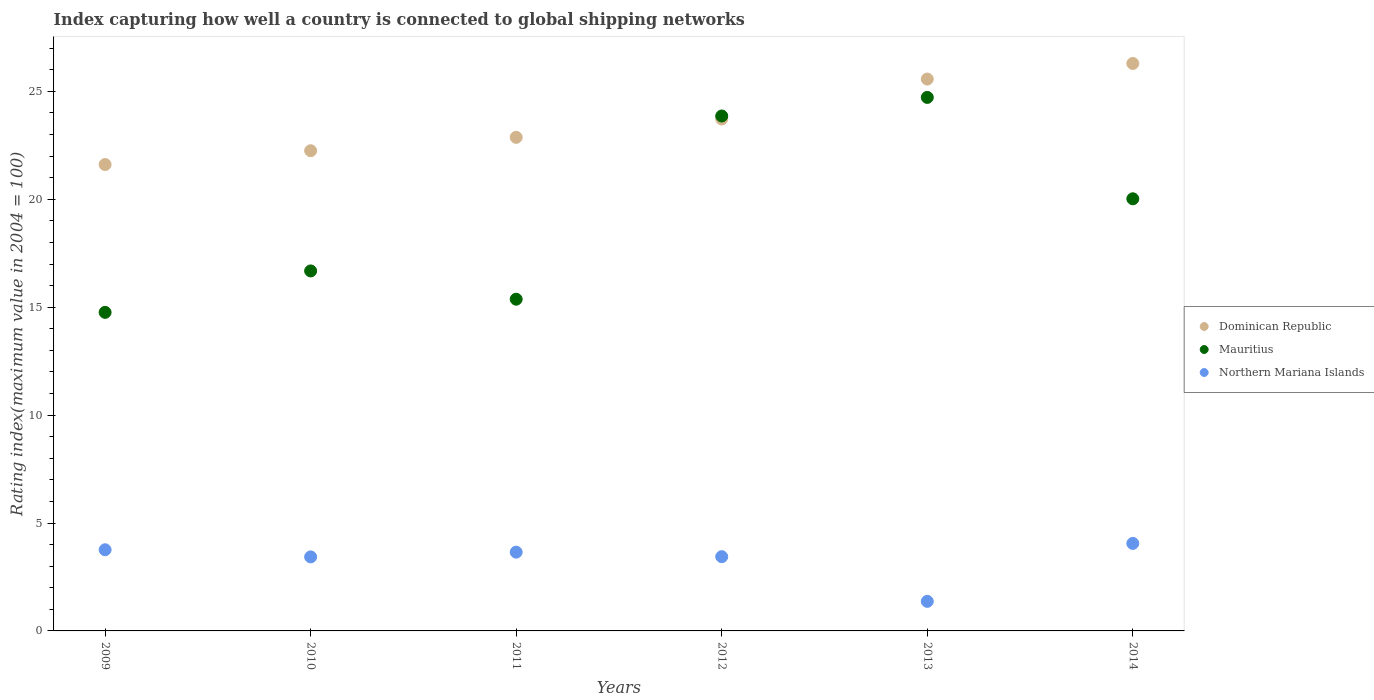What is the rating index in Dominican Republic in 2010?
Your response must be concise. 22.25. Across all years, what is the maximum rating index in Northern Mariana Islands?
Provide a short and direct response. 4.06. Across all years, what is the minimum rating index in Dominican Republic?
Offer a very short reply. 21.61. In which year was the rating index in Mauritius minimum?
Provide a short and direct response. 2009. What is the total rating index in Mauritius in the graph?
Your answer should be very brief. 115.41. What is the difference between the rating index in Dominican Republic in 2012 and that in 2013?
Your answer should be compact. -1.85. What is the difference between the rating index in Northern Mariana Islands in 2011 and the rating index in Mauritius in 2014?
Ensure brevity in your answer.  -16.37. What is the average rating index in Dominican Republic per year?
Keep it short and to the point. 23.72. In the year 2011, what is the difference between the rating index in Northern Mariana Islands and rating index in Mauritius?
Your answer should be compact. -11.72. What is the ratio of the rating index in Dominican Republic in 2010 to that in 2014?
Give a very brief answer. 0.85. Is the rating index in Northern Mariana Islands in 2009 less than that in 2012?
Your answer should be compact. No. Is the difference between the rating index in Northern Mariana Islands in 2011 and 2014 greater than the difference between the rating index in Mauritius in 2011 and 2014?
Ensure brevity in your answer.  Yes. What is the difference between the highest and the second highest rating index in Mauritius?
Your answer should be very brief. 0.86. What is the difference between the highest and the lowest rating index in Mauritius?
Ensure brevity in your answer.  9.96. Is it the case that in every year, the sum of the rating index in Mauritius and rating index in Dominican Republic  is greater than the rating index in Northern Mariana Islands?
Make the answer very short. Yes. Does the rating index in Mauritius monotonically increase over the years?
Your answer should be compact. No. How many years are there in the graph?
Provide a succinct answer. 6. What is the difference between two consecutive major ticks on the Y-axis?
Provide a short and direct response. 5. Does the graph contain any zero values?
Provide a short and direct response. No. Does the graph contain grids?
Keep it short and to the point. No. What is the title of the graph?
Your answer should be compact. Index capturing how well a country is connected to global shipping networks. Does "Vietnam" appear as one of the legend labels in the graph?
Provide a short and direct response. No. What is the label or title of the Y-axis?
Your response must be concise. Rating index(maximum value in 2004 = 100). What is the Rating index(maximum value in 2004 = 100) in Dominican Republic in 2009?
Your answer should be very brief. 21.61. What is the Rating index(maximum value in 2004 = 100) in Mauritius in 2009?
Offer a very short reply. 14.76. What is the Rating index(maximum value in 2004 = 100) of Northern Mariana Islands in 2009?
Give a very brief answer. 3.76. What is the Rating index(maximum value in 2004 = 100) in Dominican Republic in 2010?
Provide a short and direct response. 22.25. What is the Rating index(maximum value in 2004 = 100) in Mauritius in 2010?
Your answer should be very brief. 16.68. What is the Rating index(maximum value in 2004 = 100) in Northern Mariana Islands in 2010?
Your answer should be compact. 3.43. What is the Rating index(maximum value in 2004 = 100) of Dominican Republic in 2011?
Make the answer very short. 22.87. What is the Rating index(maximum value in 2004 = 100) of Mauritius in 2011?
Your answer should be compact. 15.37. What is the Rating index(maximum value in 2004 = 100) of Northern Mariana Islands in 2011?
Your answer should be compact. 3.65. What is the Rating index(maximum value in 2004 = 100) in Dominican Republic in 2012?
Your answer should be very brief. 23.72. What is the Rating index(maximum value in 2004 = 100) of Mauritius in 2012?
Give a very brief answer. 23.86. What is the Rating index(maximum value in 2004 = 100) of Northern Mariana Islands in 2012?
Offer a terse response. 3.44. What is the Rating index(maximum value in 2004 = 100) in Dominican Republic in 2013?
Your answer should be compact. 25.57. What is the Rating index(maximum value in 2004 = 100) in Mauritius in 2013?
Keep it short and to the point. 24.72. What is the Rating index(maximum value in 2004 = 100) of Northern Mariana Islands in 2013?
Offer a terse response. 1.37. What is the Rating index(maximum value in 2004 = 100) in Dominican Republic in 2014?
Your response must be concise. 26.29. What is the Rating index(maximum value in 2004 = 100) in Mauritius in 2014?
Offer a terse response. 20.02. What is the Rating index(maximum value in 2004 = 100) in Northern Mariana Islands in 2014?
Your answer should be compact. 4.06. Across all years, what is the maximum Rating index(maximum value in 2004 = 100) in Dominican Republic?
Offer a terse response. 26.29. Across all years, what is the maximum Rating index(maximum value in 2004 = 100) of Mauritius?
Your response must be concise. 24.72. Across all years, what is the maximum Rating index(maximum value in 2004 = 100) in Northern Mariana Islands?
Offer a terse response. 4.06. Across all years, what is the minimum Rating index(maximum value in 2004 = 100) of Dominican Republic?
Offer a very short reply. 21.61. Across all years, what is the minimum Rating index(maximum value in 2004 = 100) in Mauritius?
Ensure brevity in your answer.  14.76. Across all years, what is the minimum Rating index(maximum value in 2004 = 100) in Northern Mariana Islands?
Provide a short and direct response. 1.37. What is the total Rating index(maximum value in 2004 = 100) of Dominican Republic in the graph?
Make the answer very short. 142.31. What is the total Rating index(maximum value in 2004 = 100) in Mauritius in the graph?
Your answer should be compact. 115.41. What is the total Rating index(maximum value in 2004 = 100) of Northern Mariana Islands in the graph?
Your response must be concise. 19.7. What is the difference between the Rating index(maximum value in 2004 = 100) in Dominican Republic in 2009 and that in 2010?
Give a very brief answer. -0.64. What is the difference between the Rating index(maximum value in 2004 = 100) of Mauritius in 2009 and that in 2010?
Provide a short and direct response. -1.92. What is the difference between the Rating index(maximum value in 2004 = 100) in Northern Mariana Islands in 2009 and that in 2010?
Make the answer very short. 0.33. What is the difference between the Rating index(maximum value in 2004 = 100) in Dominican Republic in 2009 and that in 2011?
Make the answer very short. -1.26. What is the difference between the Rating index(maximum value in 2004 = 100) in Mauritius in 2009 and that in 2011?
Offer a terse response. -0.61. What is the difference between the Rating index(maximum value in 2004 = 100) of Northern Mariana Islands in 2009 and that in 2011?
Your response must be concise. 0.11. What is the difference between the Rating index(maximum value in 2004 = 100) in Dominican Republic in 2009 and that in 2012?
Offer a terse response. -2.11. What is the difference between the Rating index(maximum value in 2004 = 100) in Northern Mariana Islands in 2009 and that in 2012?
Offer a terse response. 0.32. What is the difference between the Rating index(maximum value in 2004 = 100) in Dominican Republic in 2009 and that in 2013?
Your answer should be very brief. -3.96. What is the difference between the Rating index(maximum value in 2004 = 100) of Mauritius in 2009 and that in 2013?
Make the answer very short. -9.96. What is the difference between the Rating index(maximum value in 2004 = 100) in Northern Mariana Islands in 2009 and that in 2013?
Provide a succinct answer. 2.39. What is the difference between the Rating index(maximum value in 2004 = 100) in Dominican Republic in 2009 and that in 2014?
Keep it short and to the point. -4.68. What is the difference between the Rating index(maximum value in 2004 = 100) of Mauritius in 2009 and that in 2014?
Your answer should be compact. -5.26. What is the difference between the Rating index(maximum value in 2004 = 100) of Northern Mariana Islands in 2009 and that in 2014?
Make the answer very short. -0.29. What is the difference between the Rating index(maximum value in 2004 = 100) of Dominican Republic in 2010 and that in 2011?
Give a very brief answer. -0.62. What is the difference between the Rating index(maximum value in 2004 = 100) of Mauritius in 2010 and that in 2011?
Offer a very short reply. 1.31. What is the difference between the Rating index(maximum value in 2004 = 100) of Northern Mariana Islands in 2010 and that in 2011?
Give a very brief answer. -0.22. What is the difference between the Rating index(maximum value in 2004 = 100) in Dominican Republic in 2010 and that in 2012?
Offer a terse response. -1.47. What is the difference between the Rating index(maximum value in 2004 = 100) in Mauritius in 2010 and that in 2012?
Make the answer very short. -7.18. What is the difference between the Rating index(maximum value in 2004 = 100) in Northern Mariana Islands in 2010 and that in 2012?
Keep it short and to the point. -0.01. What is the difference between the Rating index(maximum value in 2004 = 100) in Dominican Republic in 2010 and that in 2013?
Ensure brevity in your answer.  -3.32. What is the difference between the Rating index(maximum value in 2004 = 100) in Mauritius in 2010 and that in 2013?
Ensure brevity in your answer.  -8.04. What is the difference between the Rating index(maximum value in 2004 = 100) of Northern Mariana Islands in 2010 and that in 2013?
Offer a terse response. 2.06. What is the difference between the Rating index(maximum value in 2004 = 100) of Dominican Republic in 2010 and that in 2014?
Provide a short and direct response. -4.04. What is the difference between the Rating index(maximum value in 2004 = 100) of Mauritius in 2010 and that in 2014?
Offer a very short reply. -3.34. What is the difference between the Rating index(maximum value in 2004 = 100) in Northern Mariana Islands in 2010 and that in 2014?
Offer a very short reply. -0.62. What is the difference between the Rating index(maximum value in 2004 = 100) of Dominican Republic in 2011 and that in 2012?
Provide a short and direct response. -0.85. What is the difference between the Rating index(maximum value in 2004 = 100) of Mauritius in 2011 and that in 2012?
Your response must be concise. -8.49. What is the difference between the Rating index(maximum value in 2004 = 100) of Northern Mariana Islands in 2011 and that in 2012?
Offer a very short reply. 0.21. What is the difference between the Rating index(maximum value in 2004 = 100) in Dominican Republic in 2011 and that in 2013?
Provide a short and direct response. -2.7. What is the difference between the Rating index(maximum value in 2004 = 100) in Mauritius in 2011 and that in 2013?
Make the answer very short. -9.35. What is the difference between the Rating index(maximum value in 2004 = 100) in Northern Mariana Islands in 2011 and that in 2013?
Keep it short and to the point. 2.28. What is the difference between the Rating index(maximum value in 2004 = 100) of Dominican Republic in 2011 and that in 2014?
Ensure brevity in your answer.  -3.42. What is the difference between the Rating index(maximum value in 2004 = 100) in Mauritius in 2011 and that in 2014?
Provide a short and direct response. -4.65. What is the difference between the Rating index(maximum value in 2004 = 100) of Northern Mariana Islands in 2011 and that in 2014?
Give a very brief answer. -0.41. What is the difference between the Rating index(maximum value in 2004 = 100) in Dominican Republic in 2012 and that in 2013?
Offer a terse response. -1.85. What is the difference between the Rating index(maximum value in 2004 = 100) of Mauritius in 2012 and that in 2013?
Your answer should be very brief. -0.86. What is the difference between the Rating index(maximum value in 2004 = 100) of Northern Mariana Islands in 2012 and that in 2013?
Offer a terse response. 2.07. What is the difference between the Rating index(maximum value in 2004 = 100) of Dominican Republic in 2012 and that in 2014?
Offer a very short reply. -2.57. What is the difference between the Rating index(maximum value in 2004 = 100) of Mauritius in 2012 and that in 2014?
Keep it short and to the point. 3.84. What is the difference between the Rating index(maximum value in 2004 = 100) in Northern Mariana Islands in 2012 and that in 2014?
Give a very brief answer. -0.61. What is the difference between the Rating index(maximum value in 2004 = 100) of Dominican Republic in 2013 and that in 2014?
Offer a very short reply. -0.72. What is the difference between the Rating index(maximum value in 2004 = 100) of Mauritius in 2013 and that in 2014?
Your answer should be compact. 4.7. What is the difference between the Rating index(maximum value in 2004 = 100) in Northern Mariana Islands in 2013 and that in 2014?
Provide a succinct answer. -2.69. What is the difference between the Rating index(maximum value in 2004 = 100) in Dominican Republic in 2009 and the Rating index(maximum value in 2004 = 100) in Mauritius in 2010?
Provide a succinct answer. 4.93. What is the difference between the Rating index(maximum value in 2004 = 100) in Dominican Republic in 2009 and the Rating index(maximum value in 2004 = 100) in Northern Mariana Islands in 2010?
Keep it short and to the point. 18.18. What is the difference between the Rating index(maximum value in 2004 = 100) in Mauritius in 2009 and the Rating index(maximum value in 2004 = 100) in Northern Mariana Islands in 2010?
Offer a very short reply. 11.33. What is the difference between the Rating index(maximum value in 2004 = 100) of Dominican Republic in 2009 and the Rating index(maximum value in 2004 = 100) of Mauritius in 2011?
Offer a terse response. 6.24. What is the difference between the Rating index(maximum value in 2004 = 100) of Dominican Republic in 2009 and the Rating index(maximum value in 2004 = 100) of Northern Mariana Islands in 2011?
Give a very brief answer. 17.96. What is the difference between the Rating index(maximum value in 2004 = 100) in Mauritius in 2009 and the Rating index(maximum value in 2004 = 100) in Northern Mariana Islands in 2011?
Your response must be concise. 11.11. What is the difference between the Rating index(maximum value in 2004 = 100) in Dominican Republic in 2009 and the Rating index(maximum value in 2004 = 100) in Mauritius in 2012?
Provide a succinct answer. -2.25. What is the difference between the Rating index(maximum value in 2004 = 100) in Dominican Republic in 2009 and the Rating index(maximum value in 2004 = 100) in Northern Mariana Islands in 2012?
Offer a very short reply. 18.17. What is the difference between the Rating index(maximum value in 2004 = 100) in Mauritius in 2009 and the Rating index(maximum value in 2004 = 100) in Northern Mariana Islands in 2012?
Offer a terse response. 11.32. What is the difference between the Rating index(maximum value in 2004 = 100) in Dominican Republic in 2009 and the Rating index(maximum value in 2004 = 100) in Mauritius in 2013?
Make the answer very short. -3.11. What is the difference between the Rating index(maximum value in 2004 = 100) in Dominican Republic in 2009 and the Rating index(maximum value in 2004 = 100) in Northern Mariana Islands in 2013?
Provide a short and direct response. 20.24. What is the difference between the Rating index(maximum value in 2004 = 100) of Mauritius in 2009 and the Rating index(maximum value in 2004 = 100) of Northern Mariana Islands in 2013?
Provide a short and direct response. 13.39. What is the difference between the Rating index(maximum value in 2004 = 100) in Dominican Republic in 2009 and the Rating index(maximum value in 2004 = 100) in Mauritius in 2014?
Make the answer very short. 1.59. What is the difference between the Rating index(maximum value in 2004 = 100) in Dominican Republic in 2009 and the Rating index(maximum value in 2004 = 100) in Northern Mariana Islands in 2014?
Offer a terse response. 17.55. What is the difference between the Rating index(maximum value in 2004 = 100) of Mauritius in 2009 and the Rating index(maximum value in 2004 = 100) of Northern Mariana Islands in 2014?
Give a very brief answer. 10.71. What is the difference between the Rating index(maximum value in 2004 = 100) in Dominican Republic in 2010 and the Rating index(maximum value in 2004 = 100) in Mauritius in 2011?
Your response must be concise. 6.88. What is the difference between the Rating index(maximum value in 2004 = 100) in Mauritius in 2010 and the Rating index(maximum value in 2004 = 100) in Northern Mariana Islands in 2011?
Provide a short and direct response. 13.03. What is the difference between the Rating index(maximum value in 2004 = 100) in Dominican Republic in 2010 and the Rating index(maximum value in 2004 = 100) in Mauritius in 2012?
Ensure brevity in your answer.  -1.61. What is the difference between the Rating index(maximum value in 2004 = 100) of Dominican Republic in 2010 and the Rating index(maximum value in 2004 = 100) of Northern Mariana Islands in 2012?
Keep it short and to the point. 18.81. What is the difference between the Rating index(maximum value in 2004 = 100) of Mauritius in 2010 and the Rating index(maximum value in 2004 = 100) of Northern Mariana Islands in 2012?
Your answer should be compact. 13.24. What is the difference between the Rating index(maximum value in 2004 = 100) in Dominican Republic in 2010 and the Rating index(maximum value in 2004 = 100) in Mauritius in 2013?
Your answer should be compact. -2.47. What is the difference between the Rating index(maximum value in 2004 = 100) of Dominican Republic in 2010 and the Rating index(maximum value in 2004 = 100) of Northern Mariana Islands in 2013?
Offer a very short reply. 20.88. What is the difference between the Rating index(maximum value in 2004 = 100) of Mauritius in 2010 and the Rating index(maximum value in 2004 = 100) of Northern Mariana Islands in 2013?
Give a very brief answer. 15.31. What is the difference between the Rating index(maximum value in 2004 = 100) of Dominican Republic in 2010 and the Rating index(maximum value in 2004 = 100) of Mauritius in 2014?
Offer a very short reply. 2.23. What is the difference between the Rating index(maximum value in 2004 = 100) of Dominican Republic in 2010 and the Rating index(maximum value in 2004 = 100) of Northern Mariana Islands in 2014?
Your response must be concise. 18.2. What is the difference between the Rating index(maximum value in 2004 = 100) in Mauritius in 2010 and the Rating index(maximum value in 2004 = 100) in Northern Mariana Islands in 2014?
Offer a very short reply. 12.62. What is the difference between the Rating index(maximum value in 2004 = 100) of Dominican Republic in 2011 and the Rating index(maximum value in 2004 = 100) of Mauritius in 2012?
Give a very brief answer. -0.99. What is the difference between the Rating index(maximum value in 2004 = 100) in Dominican Republic in 2011 and the Rating index(maximum value in 2004 = 100) in Northern Mariana Islands in 2012?
Keep it short and to the point. 19.43. What is the difference between the Rating index(maximum value in 2004 = 100) in Mauritius in 2011 and the Rating index(maximum value in 2004 = 100) in Northern Mariana Islands in 2012?
Offer a terse response. 11.93. What is the difference between the Rating index(maximum value in 2004 = 100) of Dominican Republic in 2011 and the Rating index(maximum value in 2004 = 100) of Mauritius in 2013?
Ensure brevity in your answer.  -1.85. What is the difference between the Rating index(maximum value in 2004 = 100) of Dominican Republic in 2011 and the Rating index(maximum value in 2004 = 100) of Northern Mariana Islands in 2013?
Keep it short and to the point. 21.5. What is the difference between the Rating index(maximum value in 2004 = 100) of Mauritius in 2011 and the Rating index(maximum value in 2004 = 100) of Northern Mariana Islands in 2013?
Offer a terse response. 14. What is the difference between the Rating index(maximum value in 2004 = 100) in Dominican Republic in 2011 and the Rating index(maximum value in 2004 = 100) in Mauritius in 2014?
Offer a terse response. 2.85. What is the difference between the Rating index(maximum value in 2004 = 100) in Dominican Republic in 2011 and the Rating index(maximum value in 2004 = 100) in Northern Mariana Islands in 2014?
Provide a short and direct response. 18.82. What is the difference between the Rating index(maximum value in 2004 = 100) in Mauritius in 2011 and the Rating index(maximum value in 2004 = 100) in Northern Mariana Islands in 2014?
Offer a terse response. 11.31. What is the difference between the Rating index(maximum value in 2004 = 100) in Dominican Republic in 2012 and the Rating index(maximum value in 2004 = 100) in Northern Mariana Islands in 2013?
Ensure brevity in your answer.  22.35. What is the difference between the Rating index(maximum value in 2004 = 100) of Mauritius in 2012 and the Rating index(maximum value in 2004 = 100) of Northern Mariana Islands in 2013?
Make the answer very short. 22.49. What is the difference between the Rating index(maximum value in 2004 = 100) in Dominican Republic in 2012 and the Rating index(maximum value in 2004 = 100) in Mauritius in 2014?
Offer a very short reply. 3.7. What is the difference between the Rating index(maximum value in 2004 = 100) in Dominican Republic in 2012 and the Rating index(maximum value in 2004 = 100) in Northern Mariana Islands in 2014?
Provide a succinct answer. 19.66. What is the difference between the Rating index(maximum value in 2004 = 100) of Mauritius in 2012 and the Rating index(maximum value in 2004 = 100) of Northern Mariana Islands in 2014?
Keep it short and to the point. 19.8. What is the difference between the Rating index(maximum value in 2004 = 100) of Dominican Republic in 2013 and the Rating index(maximum value in 2004 = 100) of Mauritius in 2014?
Offer a very short reply. 5.55. What is the difference between the Rating index(maximum value in 2004 = 100) in Dominican Republic in 2013 and the Rating index(maximum value in 2004 = 100) in Northern Mariana Islands in 2014?
Provide a succinct answer. 21.52. What is the difference between the Rating index(maximum value in 2004 = 100) of Mauritius in 2013 and the Rating index(maximum value in 2004 = 100) of Northern Mariana Islands in 2014?
Keep it short and to the point. 20.66. What is the average Rating index(maximum value in 2004 = 100) in Dominican Republic per year?
Give a very brief answer. 23.72. What is the average Rating index(maximum value in 2004 = 100) of Mauritius per year?
Ensure brevity in your answer.  19.24. What is the average Rating index(maximum value in 2004 = 100) of Northern Mariana Islands per year?
Keep it short and to the point. 3.28. In the year 2009, what is the difference between the Rating index(maximum value in 2004 = 100) in Dominican Republic and Rating index(maximum value in 2004 = 100) in Mauritius?
Provide a short and direct response. 6.85. In the year 2009, what is the difference between the Rating index(maximum value in 2004 = 100) of Dominican Republic and Rating index(maximum value in 2004 = 100) of Northern Mariana Islands?
Give a very brief answer. 17.85. In the year 2010, what is the difference between the Rating index(maximum value in 2004 = 100) of Dominican Republic and Rating index(maximum value in 2004 = 100) of Mauritius?
Offer a very short reply. 5.57. In the year 2010, what is the difference between the Rating index(maximum value in 2004 = 100) in Dominican Republic and Rating index(maximum value in 2004 = 100) in Northern Mariana Islands?
Ensure brevity in your answer.  18.82. In the year 2010, what is the difference between the Rating index(maximum value in 2004 = 100) of Mauritius and Rating index(maximum value in 2004 = 100) of Northern Mariana Islands?
Your response must be concise. 13.25. In the year 2011, what is the difference between the Rating index(maximum value in 2004 = 100) in Dominican Republic and Rating index(maximum value in 2004 = 100) in Mauritius?
Give a very brief answer. 7.5. In the year 2011, what is the difference between the Rating index(maximum value in 2004 = 100) in Dominican Republic and Rating index(maximum value in 2004 = 100) in Northern Mariana Islands?
Offer a terse response. 19.22. In the year 2011, what is the difference between the Rating index(maximum value in 2004 = 100) of Mauritius and Rating index(maximum value in 2004 = 100) of Northern Mariana Islands?
Offer a very short reply. 11.72. In the year 2012, what is the difference between the Rating index(maximum value in 2004 = 100) in Dominican Republic and Rating index(maximum value in 2004 = 100) in Mauritius?
Make the answer very short. -0.14. In the year 2012, what is the difference between the Rating index(maximum value in 2004 = 100) in Dominican Republic and Rating index(maximum value in 2004 = 100) in Northern Mariana Islands?
Ensure brevity in your answer.  20.28. In the year 2012, what is the difference between the Rating index(maximum value in 2004 = 100) in Mauritius and Rating index(maximum value in 2004 = 100) in Northern Mariana Islands?
Provide a succinct answer. 20.42. In the year 2013, what is the difference between the Rating index(maximum value in 2004 = 100) in Dominican Republic and Rating index(maximum value in 2004 = 100) in Mauritius?
Your response must be concise. 0.85. In the year 2013, what is the difference between the Rating index(maximum value in 2004 = 100) of Dominican Republic and Rating index(maximum value in 2004 = 100) of Northern Mariana Islands?
Give a very brief answer. 24.2. In the year 2013, what is the difference between the Rating index(maximum value in 2004 = 100) of Mauritius and Rating index(maximum value in 2004 = 100) of Northern Mariana Islands?
Offer a terse response. 23.35. In the year 2014, what is the difference between the Rating index(maximum value in 2004 = 100) in Dominican Republic and Rating index(maximum value in 2004 = 100) in Mauritius?
Offer a very short reply. 6.27. In the year 2014, what is the difference between the Rating index(maximum value in 2004 = 100) in Dominican Republic and Rating index(maximum value in 2004 = 100) in Northern Mariana Islands?
Provide a succinct answer. 22.24. In the year 2014, what is the difference between the Rating index(maximum value in 2004 = 100) in Mauritius and Rating index(maximum value in 2004 = 100) in Northern Mariana Islands?
Keep it short and to the point. 15.97. What is the ratio of the Rating index(maximum value in 2004 = 100) in Dominican Republic in 2009 to that in 2010?
Your response must be concise. 0.97. What is the ratio of the Rating index(maximum value in 2004 = 100) in Mauritius in 2009 to that in 2010?
Make the answer very short. 0.88. What is the ratio of the Rating index(maximum value in 2004 = 100) in Northern Mariana Islands in 2009 to that in 2010?
Offer a very short reply. 1.1. What is the ratio of the Rating index(maximum value in 2004 = 100) of Dominican Republic in 2009 to that in 2011?
Offer a terse response. 0.94. What is the ratio of the Rating index(maximum value in 2004 = 100) in Mauritius in 2009 to that in 2011?
Provide a short and direct response. 0.96. What is the ratio of the Rating index(maximum value in 2004 = 100) in Northern Mariana Islands in 2009 to that in 2011?
Offer a very short reply. 1.03. What is the ratio of the Rating index(maximum value in 2004 = 100) in Dominican Republic in 2009 to that in 2012?
Make the answer very short. 0.91. What is the ratio of the Rating index(maximum value in 2004 = 100) of Mauritius in 2009 to that in 2012?
Offer a very short reply. 0.62. What is the ratio of the Rating index(maximum value in 2004 = 100) in Northern Mariana Islands in 2009 to that in 2012?
Give a very brief answer. 1.09. What is the ratio of the Rating index(maximum value in 2004 = 100) in Dominican Republic in 2009 to that in 2013?
Offer a terse response. 0.85. What is the ratio of the Rating index(maximum value in 2004 = 100) of Mauritius in 2009 to that in 2013?
Your answer should be very brief. 0.6. What is the ratio of the Rating index(maximum value in 2004 = 100) of Northern Mariana Islands in 2009 to that in 2013?
Give a very brief answer. 2.74. What is the ratio of the Rating index(maximum value in 2004 = 100) of Dominican Republic in 2009 to that in 2014?
Make the answer very short. 0.82. What is the ratio of the Rating index(maximum value in 2004 = 100) in Mauritius in 2009 to that in 2014?
Provide a succinct answer. 0.74. What is the ratio of the Rating index(maximum value in 2004 = 100) of Northern Mariana Islands in 2009 to that in 2014?
Offer a terse response. 0.93. What is the ratio of the Rating index(maximum value in 2004 = 100) in Dominican Republic in 2010 to that in 2011?
Your response must be concise. 0.97. What is the ratio of the Rating index(maximum value in 2004 = 100) in Mauritius in 2010 to that in 2011?
Make the answer very short. 1.09. What is the ratio of the Rating index(maximum value in 2004 = 100) of Northern Mariana Islands in 2010 to that in 2011?
Provide a short and direct response. 0.94. What is the ratio of the Rating index(maximum value in 2004 = 100) of Dominican Republic in 2010 to that in 2012?
Offer a terse response. 0.94. What is the ratio of the Rating index(maximum value in 2004 = 100) of Mauritius in 2010 to that in 2012?
Make the answer very short. 0.7. What is the ratio of the Rating index(maximum value in 2004 = 100) in Dominican Republic in 2010 to that in 2013?
Your answer should be very brief. 0.87. What is the ratio of the Rating index(maximum value in 2004 = 100) in Mauritius in 2010 to that in 2013?
Keep it short and to the point. 0.67. What is the ratio of the Rating index(maximum value in 2004 = 100) in Northern Mariana Islands in 2010 to that in 2013?
Make the answer very short. 2.5. What is the ratio of the Rating index(maximum value in 2004 = 100) of Dominican Republic in 2010 to that in 2014?
Keep it short and to the point. 0.85. What is the ratio of the Rating index(maximum value in 2004 = 100) of Mauritius in 2010 to that in 2014?
Give a very brief answer. 0.83. What is the ratio of the Rating index(maximum value in 2004 = 100) of Northern Mariana Islands in 2010 to that in 2014?
Ensure brevity in your answer.  0.85. What is the ratio of the Rating index(maximum value in 2004 = 100) in Dominican Republic in 2011 to that in 2012?
Provide a succinct answer. 0.96. What is the ratio of the Rating index(maximum value in 2004 = 100) of Mauritius in 2011 to that in 2012?
Provide a succinct answer. 0.64. What is the ratio of the Rating index(maximum value in 2004 = 100) in Northern Mariana Islands in 2011 to that in 2012?
Provide a succinct answer. 1.06. What is the ratio of the Rating index(maximum value in 2004 = 100) of Dominican Republic in 2011 to that in 2013?
Give a very brief answer. 0.89. What is the ratio of the Rating index(maximum value in 2004 = 100) of Mauritius in 2011 to that in 2013?
Provide a short and direct response. 0.62. What is the ratio of the Rating index(maximum value in 2004 = 100) of Northern Mariana Islands in 2011 to that in 2013?
Make the answer very short. 2.66. What is the ratio of the Rating index(maximum value in 2004 = 100) of Dominican Republic in 2011 to that in 2014?
Provide a short and direct response. 0.87. What is the ratio of the Rating index(maximum value in 2004 = 100) of Mauritius in 2011 to that in 2014?
Provide a succinct answer. 0.77. What is the ratio of the Rating index(maximum value in 2004 = 100) of Northern Mariana Islands in 2011 to that in 2014?
Keep it short and to the point. 0.9. What is the ratio of the Rating index(maximum value in 2004 = 100) in Dominican Republic in 2012 to that in 2013?
Keep it short and to the point. 0.93. What is the ratio of the Rating index(maximum value in 2004 = 100) of Mauritius in 2012 to that in 2013?
Provide a short and direct response. 0.97. What is the ratio of the Rating index(maximum value in 2004 = 100) of Northern Mariana Islands in 2012 to that in 2013?
Your response must be concise. 2.51. What is the ratio of the Rating index(maximum value in 2004 = 100) of Dominican Republic in 2012 to that in 2014?
Make the answer very short. 0.9. What is the ratio of the Rating index(maximum value in 2004 = 100) of Mauritius in 2012 to that in 2014?
Your answer should be very brief. 1.19. What is the ratio of the Rating index(maximum value in 2004 = 100) of Northern Mariana Islands in 2012 to that in 2014?
Your response must be concise. 0.85. What is the ratio of the Rating index(maximum value in 2004 = 100) of Dominican Republic in 2013 to that in 2014?
Your answer should be very brief. 0.97. What is the ratio of the Rating index(maximum value in 2004 = 100) in Mauritius in 2013 to that in 2014?
Ensure brevity in your answer.  1.23. What is the ratio of the Rating index(maximum value in 2004 = 100) of Northern Mariana Islands in 2013 to that in 2014?
Your response must be concise. 0.34. What is the difference between the highest and the second highest Rating index(maximum value in 2004 = 100) of Dominican Republic?
Offer a very short reply. 0.72. What is the difference between the highest and the second highest Rating index(maximum value in 2004 = 100) in Mauritius?
Your answer should be very brief. 0.86. What is the difference between the highest and the second highest Rating index(maximum value in 2004 = 100) of Northern Mariana Islands?
Your response must be concise. 0.29. What is the difference between the highest and the lowest Rating index(maximum value in 2004 = 100) in Dominican Republic?
Offer a very short reply. 4.68. What is the difference between the highest and the lowest Rating index(maximum value in 2004 = 100) in Mauritius?
Offer a terse response. 9.96. What is the difference between the highest and the lowest Rating index(maximum value in 2004 = 100) of Northern Mariana Islands?
Your answer should be very brief. 2.69. 